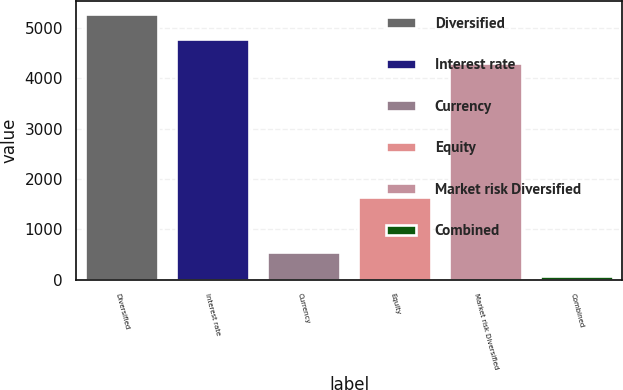Convert chart. <chart><loc_0><loc_0><loc_500><loc_500><bar_chart><fcel>Diversified<fcel>Interest rate<fcel>Currency<fcel>Equity<fcel>Market risk Diversified<fcel>Combined<nl><fcel>5264.6<fcel>4785.8<fcel>542.8<fcel>1650<fcel>4307<fcel>64<nl></chart> 